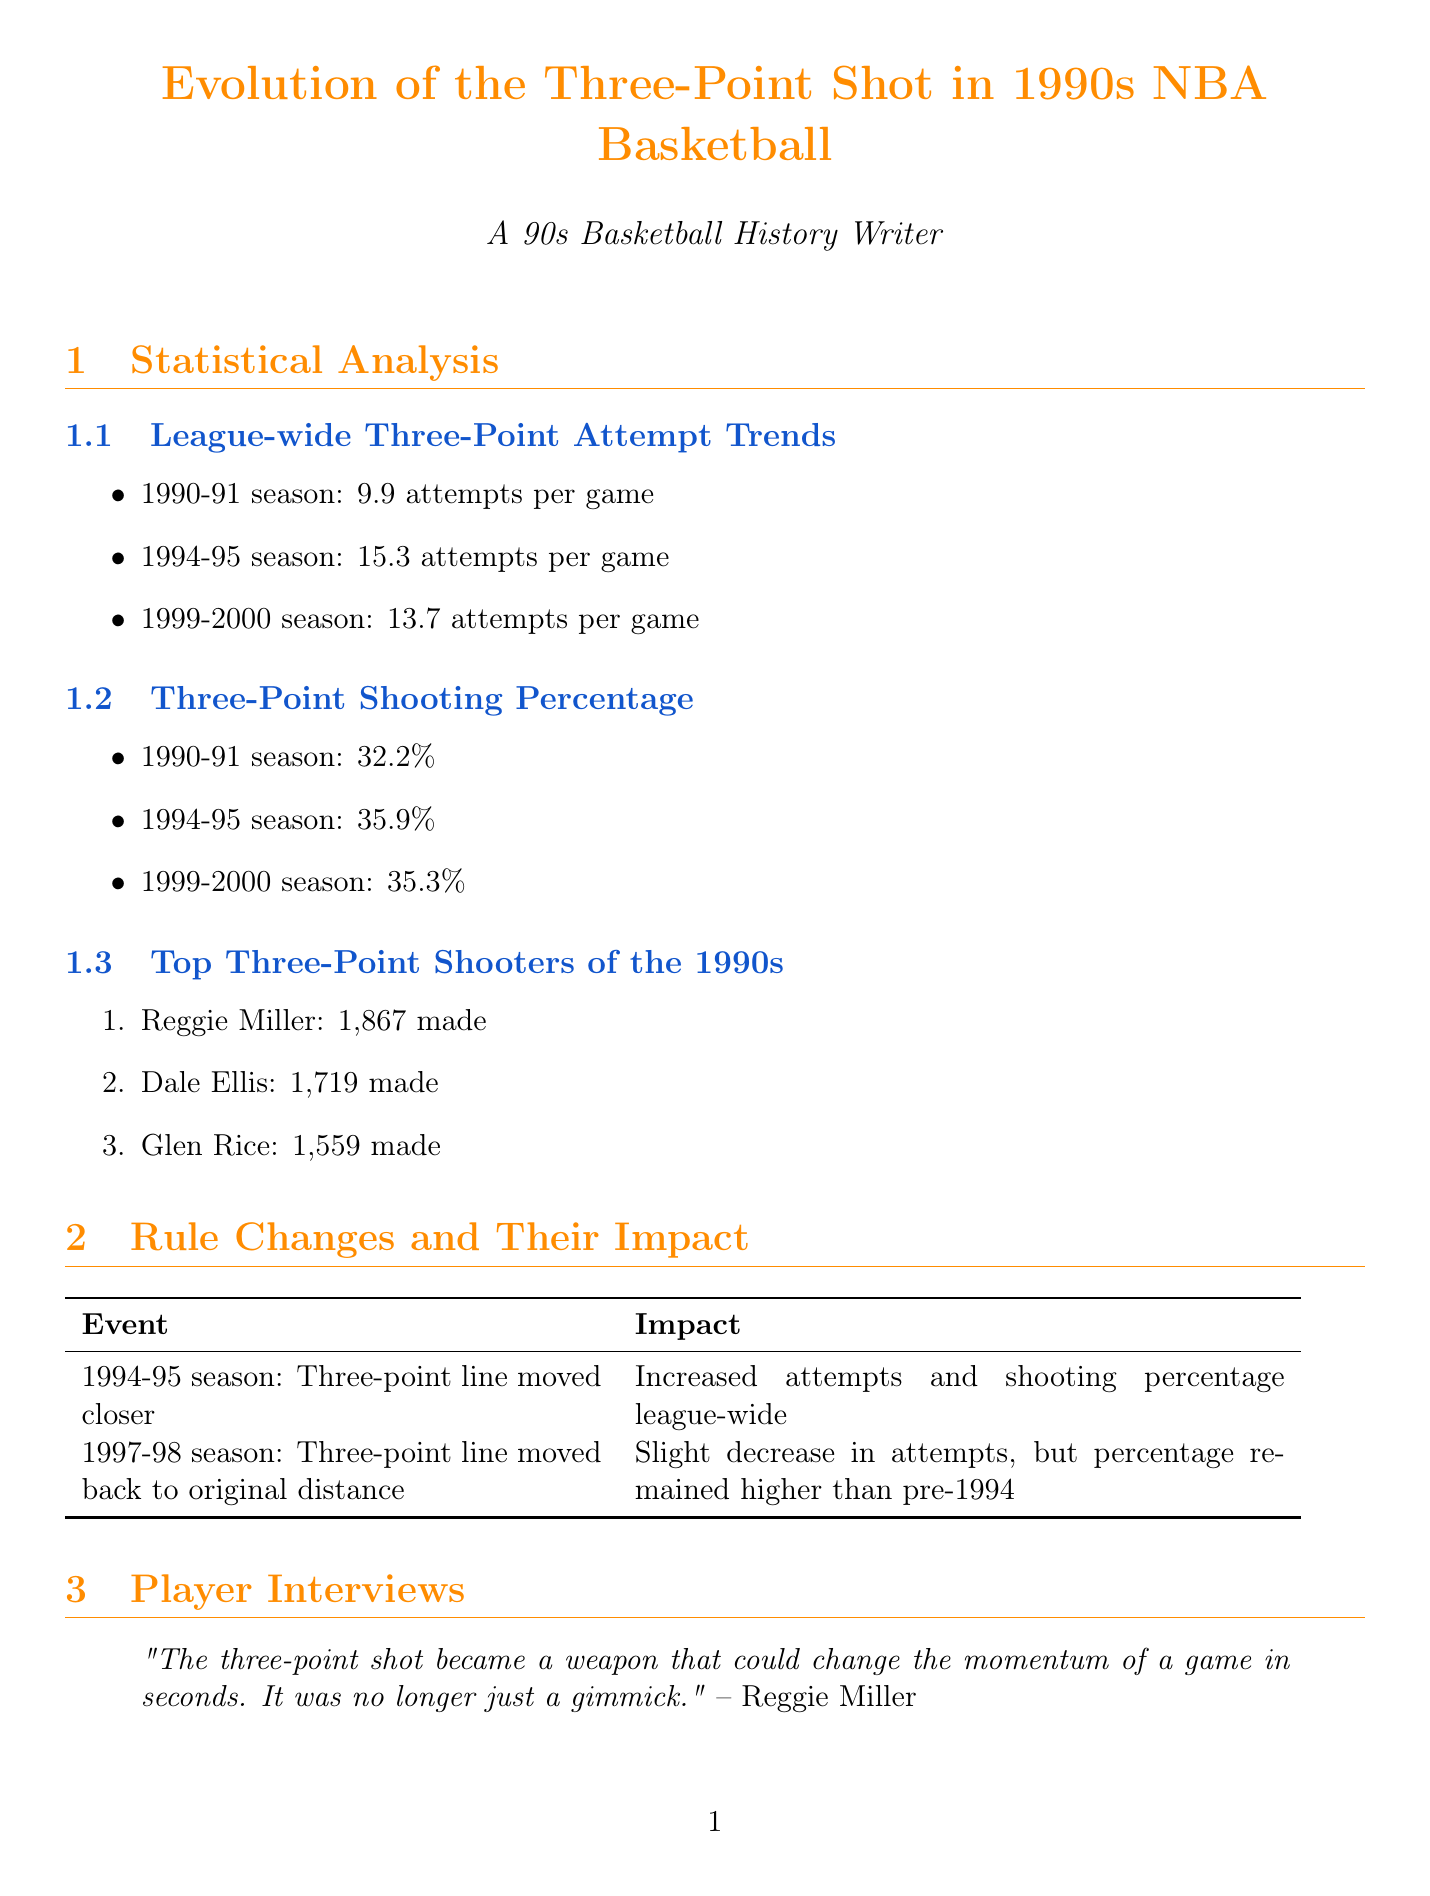What was the average number of three-point attempts per game in the 1994-95 season? The document states that there were 15.3 attempts per game in the 1994-95 season.
Answer: 15.3 attempts per game Who set the NBA record for three-pointers made in a game in 1996? According to the document, Dennis Scott set this record with 11 three-pointers.
Answer: Dennis Scott What impact did the three-point line moving closer in the 1994-95 season have on shooting percentage? The document notes that the change led to an increased shooting percentage league-wide.
Answer: Increased shooting percentage How many three-pointers did Reggie Miller make in the 1990s? The document indicates that Reggie Miller made 1,867 three-pointers.
Answer: 1,867 made Which team utilized three-point specialists like Steve Kerr and Craig Hodges? The document mentions that the Chicago Bulls utilized these specialists to complement their star players.
Answer: Chicago Bulls What percentage was the three-point shooting average in the 1990-91 season? According to the document, the percentage was 32.2%.
Answer: 32.2% Which notable player said that when the three-point line was moved in, it felt like a layup? The document states that this quote was made by Dennis Scott.
Answer: Dennis Scott What significant player development trend arose during the 1990s? The document notes an increased emphasis on three-point shooting in player training.
Answer: Increased emphasis on three-point shooting 